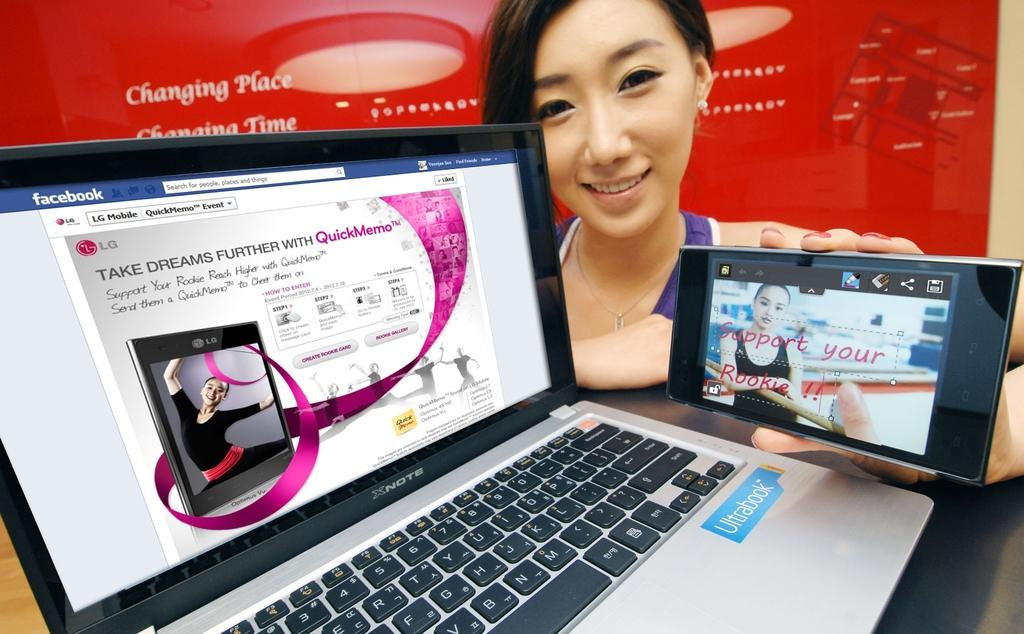<image>
Write a terse but informative summary of the picture. Woman holding a tablet next to an Ultrabook that says, support your rookie. 